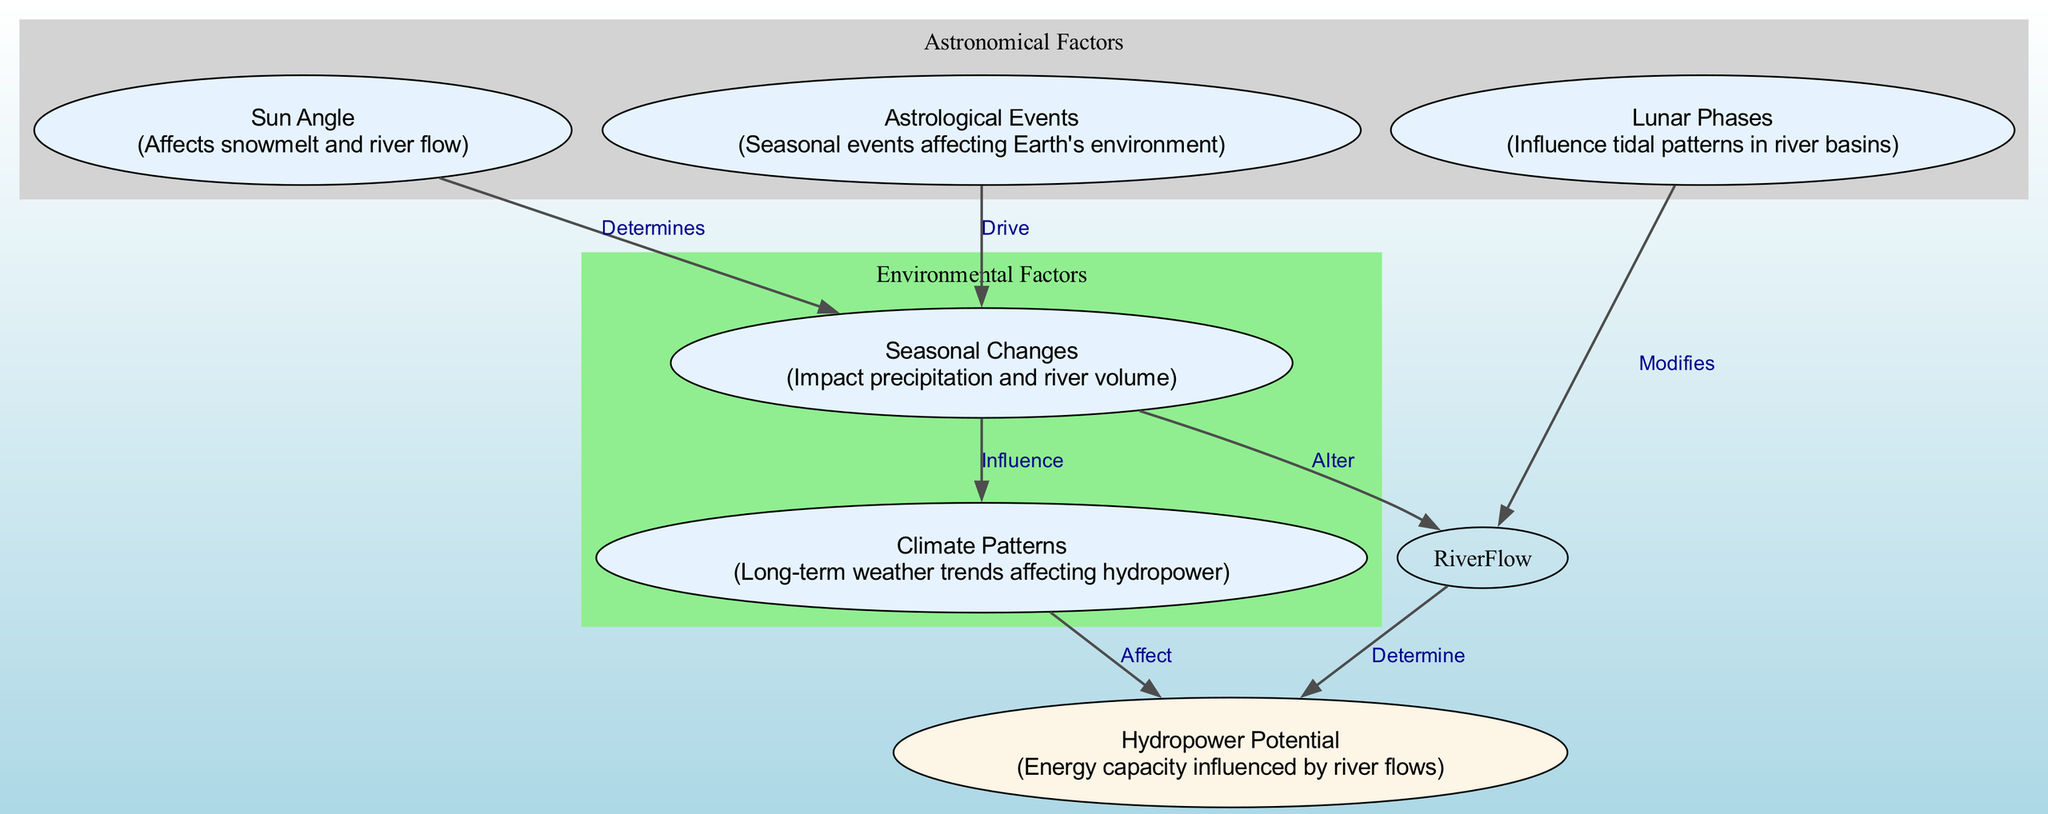What is the total number of nodes in the diagram? The diagram includes six nodes: Sun Angle, Lunar Phases, Seasonal Changes, Hydropower Potential, Astrological Events, and Climate Patterns. By counting these nodes, we find that there are six in total.
Answer: 6 What relationship does the Sun Angle have with Seasonal Changes? The diagram shows a direct relationship where the Sun Angle is indicated to determine Seasonal Changes, as represented by the directed edge connecting these two nodes.
Answer: Determines Which node is influenced by Climate Patterns? The diagram reveals that the Hydropower Potential is affected by Climate Patterns, as there is a directed edge from Climate Patterns to Hydropower Potential.
Answer: Hydropower Potential How many edges connect Astrological Events to other nodes? By examining the edges, we see that there is one edge originating from Astrological Events, linking it to Seasonal Changes. Thus, there is only one edge connecting Astrological Events to another node.
Answer: 1 What effect do Lunar Phases have on River Flow? The diagram indicates that Lunar Phases modify River Flow, which is depicted by a directed relation specified on the edge from Lunar Phases to River Flow.
Answer: Modifies What determines Hydropower Potential according to the diagram? The diagram illustrates that Hydropower Potential is determined by two factors: River Flow and Climate Patterns. Therefore, both of these nodes contribute to determining Hydropower Potential.
Answer: River Flow and Climate Patterns How do Astrological Events affect Seasonal Changes? The diagram explicitly indicates that Astrological Events drive Seasonal Changes, as denoted by the directed edge flowing from Astrological Events to Seasonal Changes, showing how changes in the astrological context can influence seasonal weather patterns.
Answer: Drive Which two factors can alter River Flow? The diagram shows that both Seasonal Changes and Lunar Phases have effects on River Flow, with edges indicating that Seasonal Changes alter River Flow and Lunar Phases modify it.
Answer: Seasonal Changes and Lunar Phases 